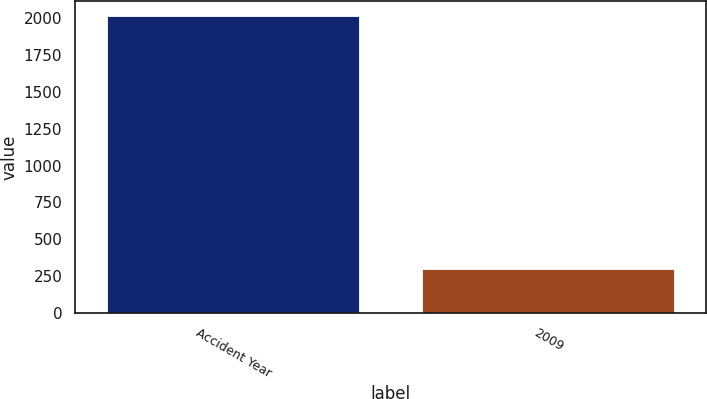Convert chart. <chart><loc_0><loc_0><loc_500><loc_500><bar_chart><fcel>Accident Year<fcel>2009<nl><fcel>2017<fcel>301<nl></chart> 